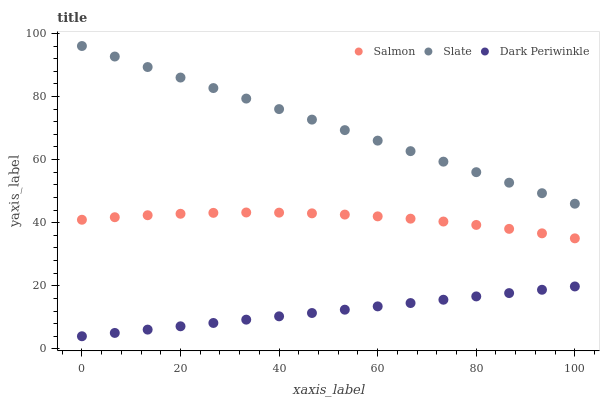Does Dark Periwinkle have the minimum area under the curve?
Answer yes or no. Yes. Does Slate have the maximum area under the curve?
Answer yes or no. Yes. Does Salmon have the minimum area under the curve?
Answer yes or no. No. Does Salmon have the maximum area under the curve?
Answer yes or no. No. Is Dark Periwinkle the smoothest?
Answer yes or no. Yes. Is Salmon the roughest?
Answer yes or no. Yes. Is Salmon the smoothest?
Answer yes or no. No. Is Dark Periwinkle the roughest?
Answer yes or no. No. Does Dark Periwinkle have the lowest value?
Answer yes or no. Yes. Does Salmon have the lowest value?
Answer yes or no. No. Does Slate have the highest value?
Answer yes or no. Yes. Does Salmon have the highest value?
Answer yes or no. No. Is Dark Periwinkle less than Slate?
Answer yes or no. Yes. Is Salmon greater than Dark Periwinkle?
Answer yes or no. Yes. Does Dark Periwinkle intersect Slate?
Answer yes or no. No. 